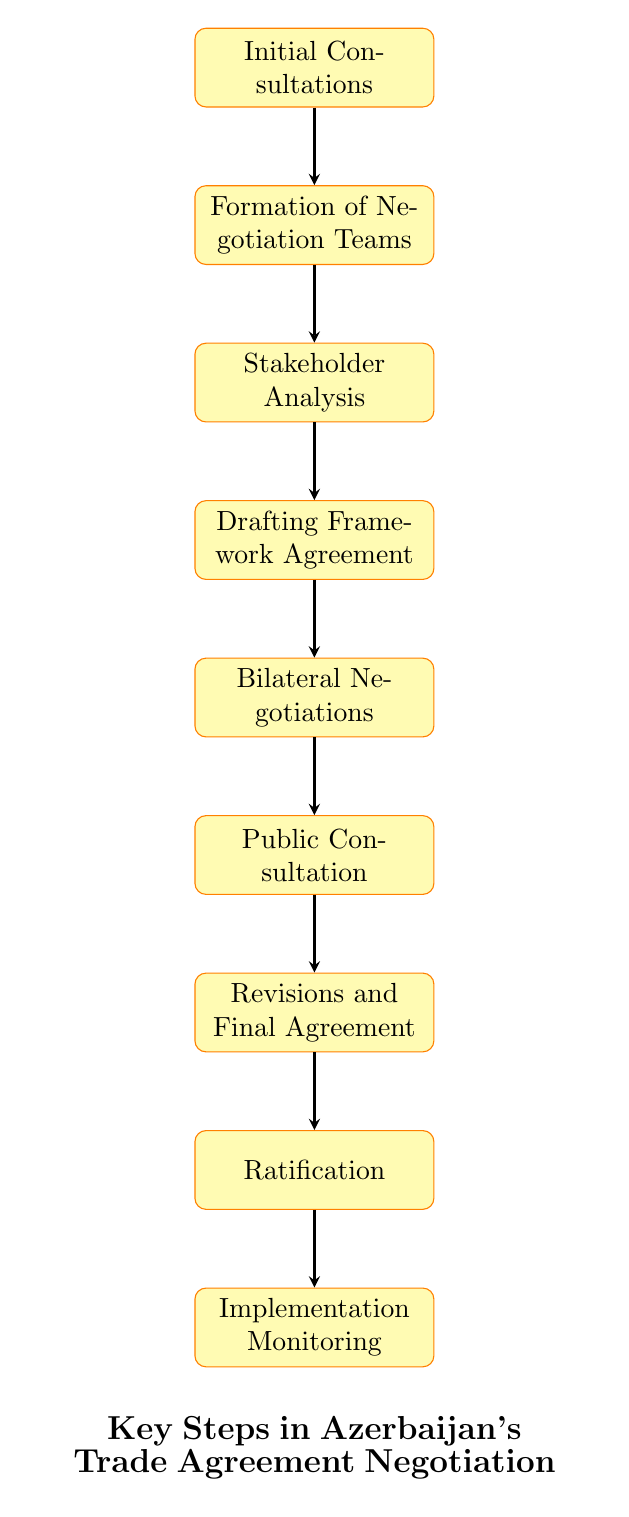What is the first step in the negotiation process? The first step is labeled as "Initial Consultations," which is the starting point of the flow chart.
Answer: Initial Consultations How many nodes are in the diagram? The diagram contains 9 nodes, each representing a key step in Azerbaijan's trade agreement negotiation process.
Answer: 9 What comes after "Bilateral Negotiations"? The step that follows "Bilateral Negotiations" is "Public Consultation," indicating the sequence of the negotiation process.
Answer: Public Consultation Which step involves feedback from the public and private sectors? "Public Consultation" is the step dedicated to engaging with the public and private sectors for their feedback.
Answer: Public Consultation What is the final step in the negotiation process? The last step is "Implementation Monitoring," which indicates that this stage comes after all agreement processes are completed.
Answer: Implementation Monitoring Which two steps are closely linked by an arrow? "Drafting Framework Agreement" and "Bilateral Negotiations" are directly connected and follow sequentially in the flow of the process.
Answer: Drafting Framework Agreement and Bilateral Negotiations How many edges connect the nodes? There are 8 edges in the flow chart, representing the connections between each step in the negotiation process.
Answer: 8 What type of agreement is being negotiated in this process? The type of agreement being negotiated is a trade agreement, focusing on terms, tariffs, and regulatory standards.
Answer: Trade Agreement What step comes immediately before "Revisions and Final Agreement"? The step that comes immediately before "Revisions and Final Agreement" is "Public Consultation," crucial for feedback before finalizing the agreement.
Answer: Public Consultation 